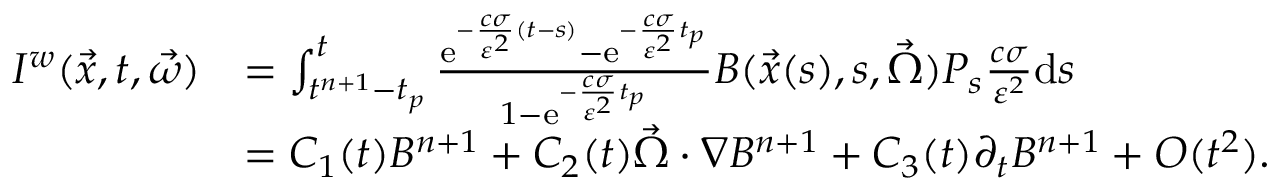<formula> <loc_0><loc_0><loc_500><loc_500>\begin{array} { r l } { I ^ { w } ( \vec { x } , t , \vec { \omega } ) } & { = \int _ { t ^ { n + 1 } - t _ { p } } ^ { t } \frac { e ^ { - \frac { c \sigma } { \varepsilon ^ { 2 } } ( t - s ) } - e ^ { - \frac { c \sigma } { \varepsilon ^ { 2 } } t _ { p } } } { 1 - e ^ { - \frac { c \sigma } { \varepsilon ^ { 2 } } t _ { p } } } B ( \vec { x } ( s ) , s , \vec { \Omega } ) P _ { s } \frac { c \sigma } { \varepsilon ^ { 2 } } d s } \\ & { = C _ { 1 } ( t ) B ^ { n + 1 } + C _ { 2 } ( t ) \vec { \Omega } \cdot \nabla B ^ { n + 1 } + C _ { 3 } ( t ) \partial _ { t } B ^ { n + 1 } + O ( t ^ { 2 } ) . } \end{array}</formula> 